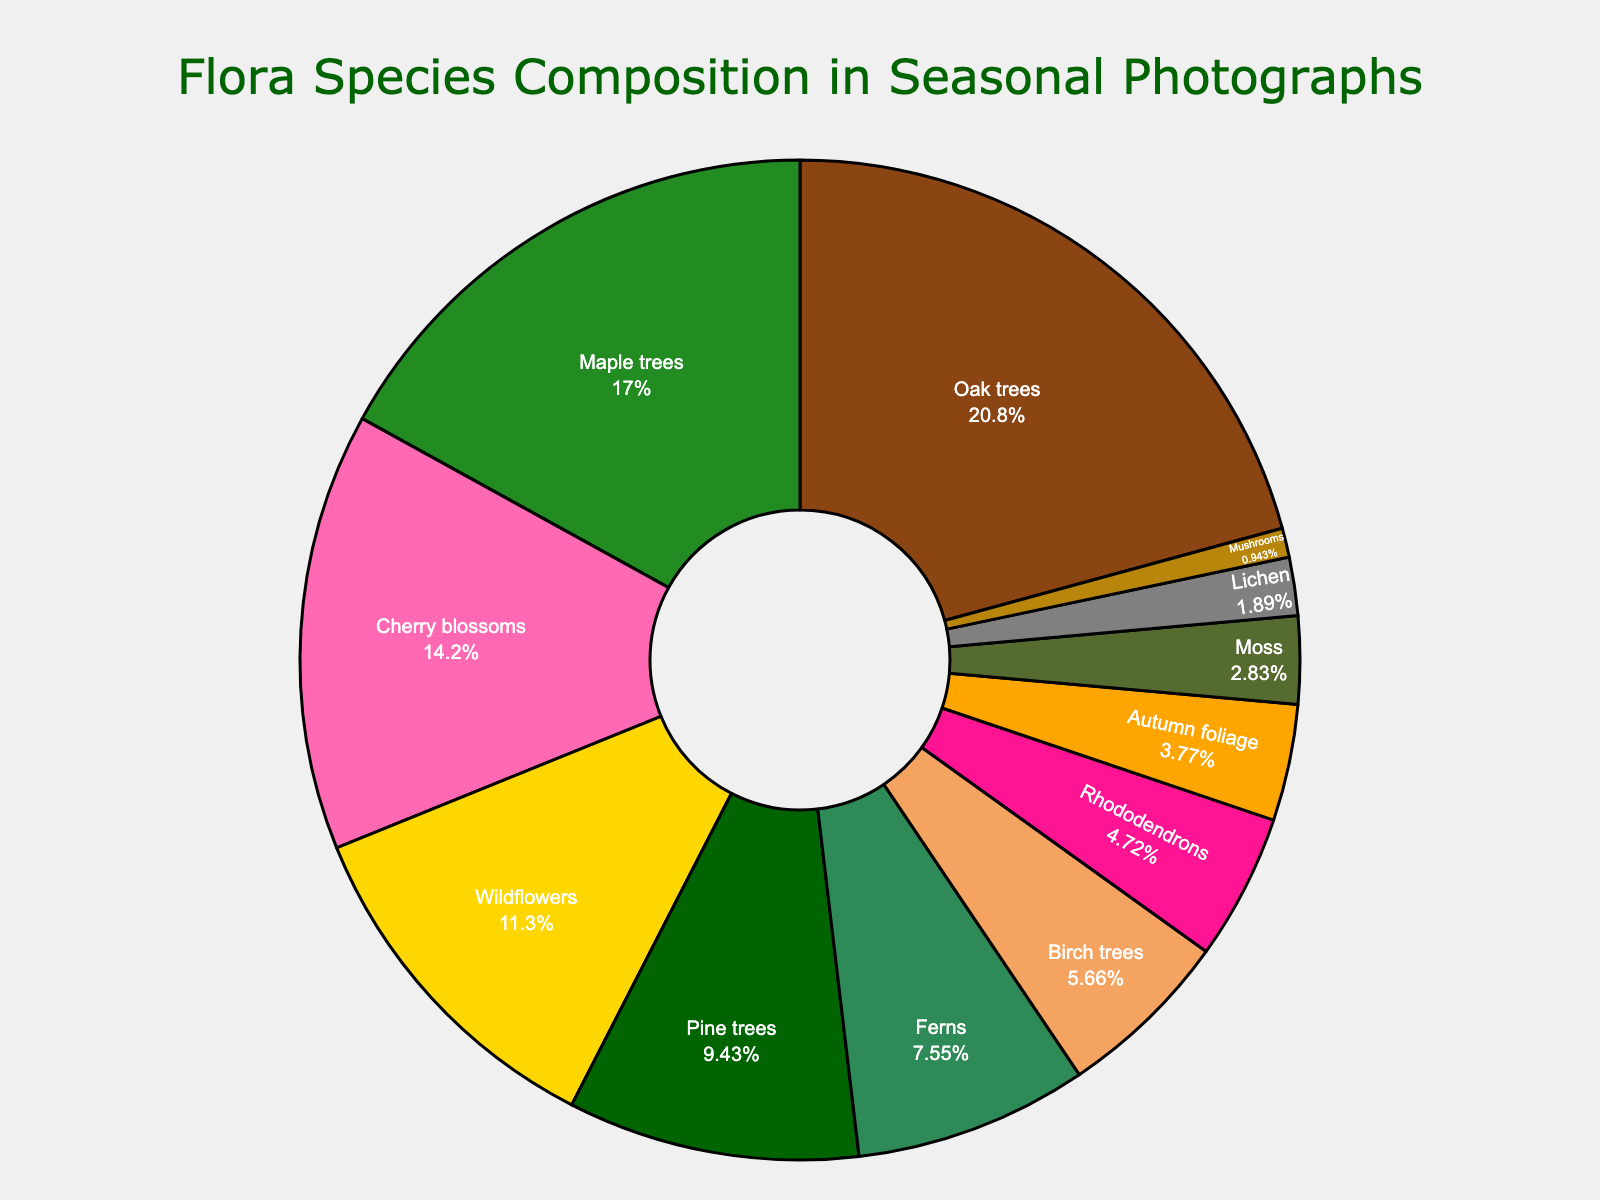What species has the highest percentage in the pie chart? The largest segment in the pie chart is for Oak trees.
Answer: Oak trees How much higher is the percentage of Oak trees compared to Pine trees? Oak trees have 22% and Pine trees have 10%. The difference is 22% - 10% = 12%.
Answer: 12% What is the sum of the percentages for Wildflowers, Ferns, and Moss? Wildflowers have 12%, Ferns have 8%, and Moss has 3%. Their sum is 12% + 8% + 3% = 23%.
Answer: 23% What species has the smallest representation in the photographs? The smallest segment in the pie chart is for Mushrooms with 1%.
Answer: Mushrooms Are there more Cherry blossoms or Maple trees captured in the photographs? Maple trees have a smaller percentage at 18% compared to Cherry blossoms which have 15%.
Answer: Maple trees Which species has a visual segment colored in bright pink in the pie chart? The bright pink colored segment represents Cherry blossoms.
Answer: Cherry blossoms How does the percentage of Birch trees compare to the sum of Rhododendrons and Lichen? Birch trees have 6%, while Rhododendrons have 5% and Lichen has 2%. Sum of Rhododendrons and Lichen is 5% + 2% = 7%, which is more than 6%.
Answer: Less than What’s the average percentage of Oak trees, Maple trees, and Pine trees? Oak trees have 22%, Maple trees have 18%, and Pine trees have 10%. Their sum is 22% + 18% + 10% = 50%. The average is 50% / 3 = 16.67%.
Answer: 16.67% Is the percentage of Autumn Foliage higher than the percentage of Ferns? Autumn foliage has 4%, while Ferns have 8%. 4% is less than 8%.
Answer: No In terms of visual representation, which species is depicted by the green colored segment in the pie chart? The green-colored segment corresponds to Maples trees, which are often represented by green.
Answer: Maple trees 